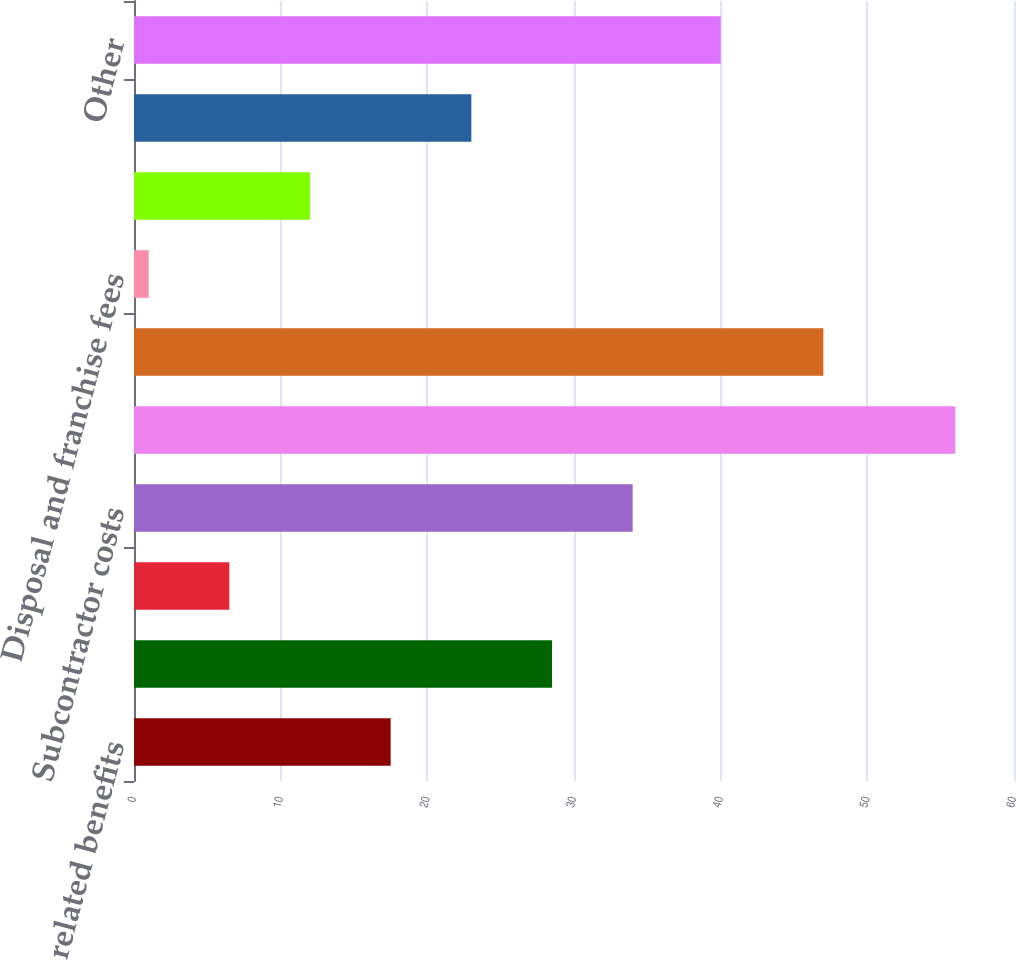<chart> <loc_0><loc_0><loc_500><loc_500><bar_chart><fcel>Labor and related benefits<fcel>Transfer and disposal costs<fcel>Maintenance and repairs<fcel>Subcontractor costs<fcel>Cost of goods sold<fcel>Fuel<fcel>Disposal and franchise fees<fcel>Landfill operating costs<fcel>Risk management<fcel>Other<nl><fcel>17.5<fcel>28.5<fcel>6.5<fcel>34<fcel>56<fcel>47<fcel>1<fcel>12<fcel>23<fcel>40<nl></chart> 